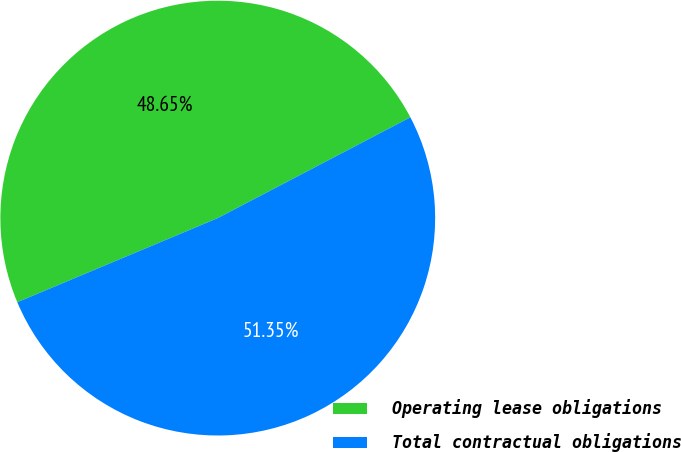Convert chart. <chart><loc_0><loc_0><loc_500><loc_500><pie_chart><fcel>Operating lease obligations<fcel>Total contractual obligations<nl><fcel>48.65%<fcel>51.35%<nl></chart> 